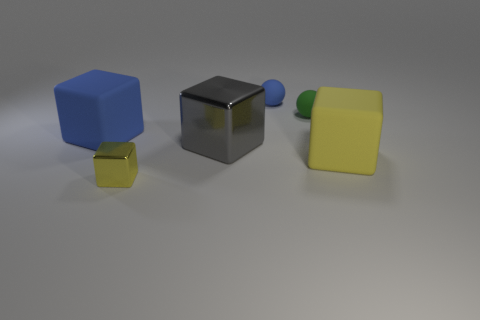There is a small object that is both on the left side of the green ball and to the right of the big shiny cube; what is its material?
Keep it short and to the point. Rubber. Is the number of large matte cubes to the left of the large metallic object the same as the number of tiny spheres?
Provide a succinct answer. No. How many tiny things have the same shape as the large yellow object?
Your answer should be compact. 1. There is a rubber object in front of the large rubber thing behind the big object that is to the right of the green thing; what is its size?
Keep it short and to the point. Large. Do the yellow block behind the tiny yellow cube and the blue cube have the same material?
Make the answer very short. Yes. Are there an equal number of big cubes that are to the left of the green thing and large metal things to the left of the large blue cube?
Make the answer very short. No. Are there any other things that are the same size as the blue cube?
Provide a succinct answer. Yes. There is another large yellow object that is the same shape as the big shiny object; what is it made of?
Provide a succinct answer. Rubber. There is a rubber cube that is on the left side of the large rubber block that is right of the blue matte block; is there a yellow metal thing in front of it?
Give a very brief answer. Yes. There is a shiny thing that is to the right of the small yellow block; is it the same shape as the blue rubber object in front of the tiny blue rubber sphere?
Your answer should be very brief. Yes. 